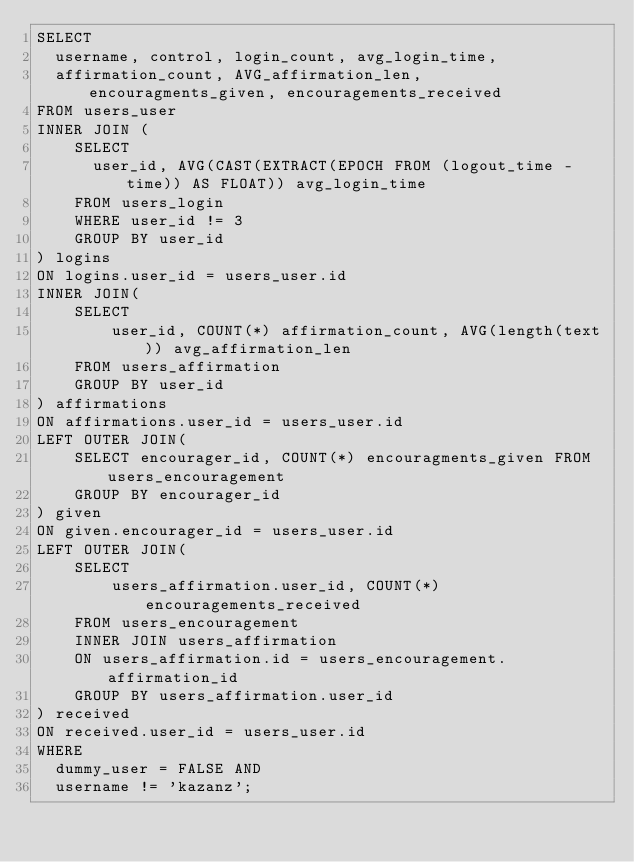<code> <loc_0><loc_0><loc_500><loc_500><_SQL_>SELECT 
  username, control, login_count, avg_login_time,
  affirmation_count, AVG_affirmation_len, encouragments_given, encouragements_received
FROM users_user
INNER JOIN (
    SELECT
      user_id, AVG(CAST(EXTRACT(EPOCH FROM (logout_time - time)) AS FLOAT)) avg_login_time
    FROM users_login
    WHERE user_id != 3
    GROUP BY user_id
) logins
ON logins.user_id = users_user.id
INNER JOIN(
    SELECT
        user_id, COUNT(*) affirmation_count, AVG(length(text)) avg_affirmation_len
    FROM users_affirmation
    GROUP BY user_id
) affirmations
ON affirmations.user_id = users_user.id
LEFT OUTER JOIN(
    SELECT encourager_id, COUNT(*) encouragments_given FROM users_encouragement
    GROUP BY encourager_id
) given
ON given.encourager_id = users_user.id
LEFT OUTER JOIN(
    SELECT
        users_affirmation.user_id, COUNT(*) encouragements_received
    FROM users_encouragement
    INNER JOIN users_affirmation
    ON users_affirmation.id = users_encouragement.affirmation_id
    GROUP BY users_affirmation.user_id
) received
ON received.user_id = users_user.id
WHERE
  dummy_user = FALSE AND
  username != 'kazanz';
</code> 